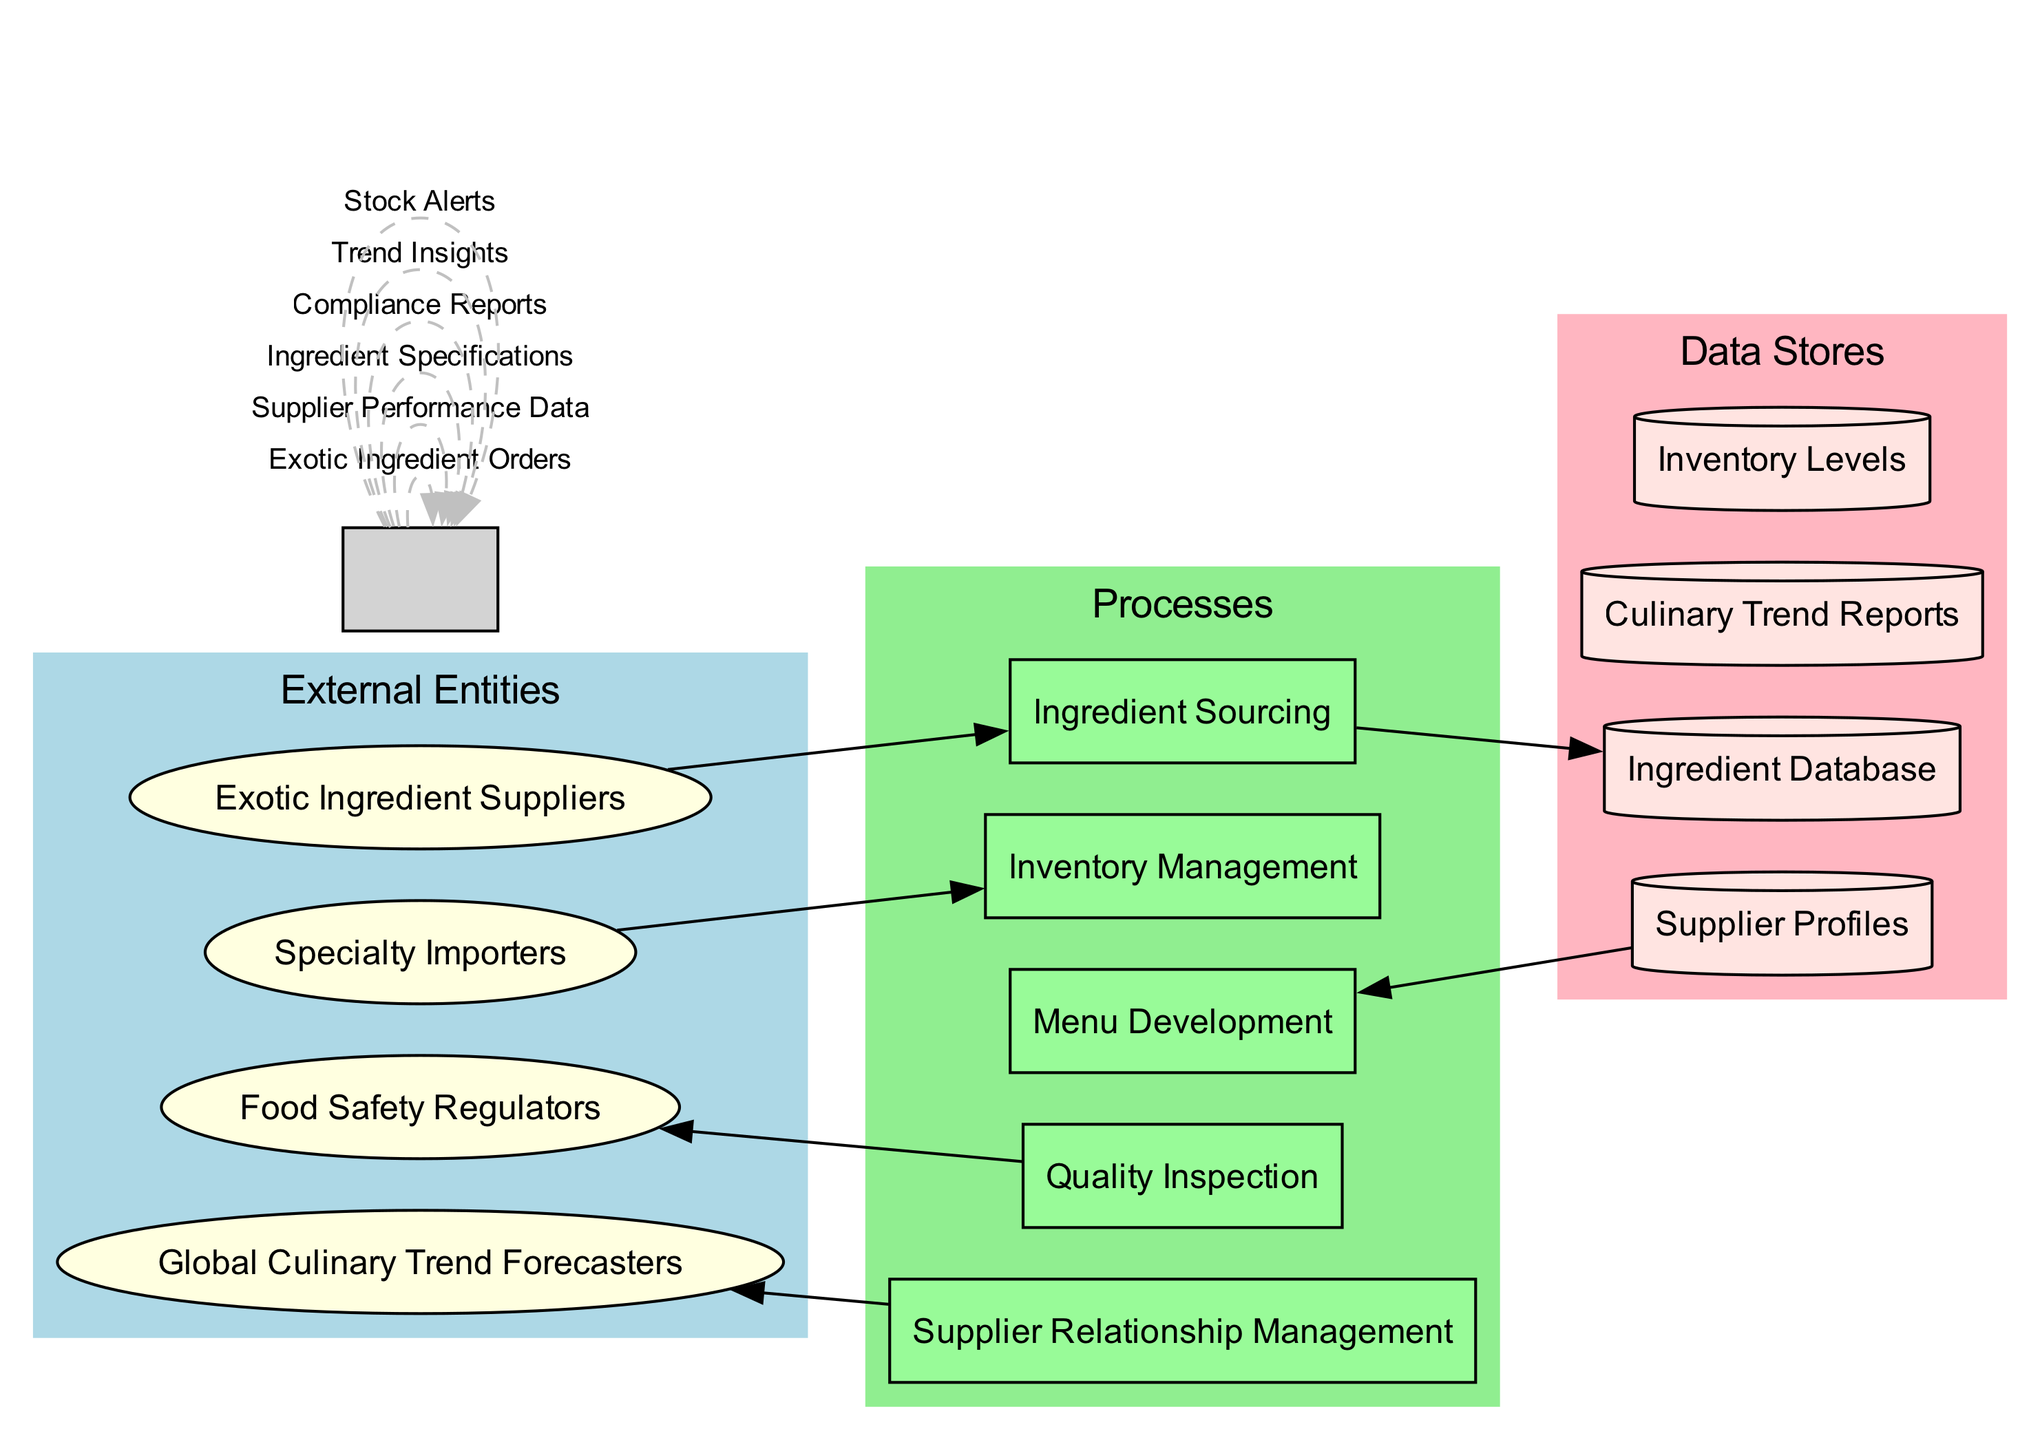What are the external entities listed in the diagram? The diagram lists four external entities: Exotic Ingredient Suppliers, Food Safety Regulators, Specialty Importers, and Global Culinary Trend Forecasters. These are shown as ovals in the "External Entities" section of the diagram.
Answer: Exotic Ingredient Suppliers, Food Safety Regulators, Specialty Importers, Global Culinary Trend Forecasters How many processes are there in the diagram? There are five processes: Ingredient Sourcing, Quality Inspection, Menu Development, Inventory Management, and Supplier Relationship Management. Each of these is represented as a rectangle in the "Processes" section of the diagram.
Answer: Five Which process is connected to Supplier Relationship Management? The Supplier Relationship Management process is connected to the Global Culinary Trend Forecasters external entity. This connection indicates a flow of information from the forecasters to the management process.
Answer: Global Culinary Trend Forecasters What type of data store is used for tracking inventory levels? Inventory Levels is represented as a cylinder in the diagram, which indicates it is a data store specifically used to track inventory levels. The cylinder shape is standard in data flow diagrams to denote data stores.
Answer: Cylinder Which data flow is labeled as "Trend Insights"? The "Trend Insights" data flow connects the Global Culinary Trend Forecasters to the Supplier Relationship Management process, indicating the transfer of insights into culinary trends from external forecasters to the management process.
Answer: Supplier Relationship Management What is the flow between Ingredient Sourcing and the Ingredient Database? The flow between Ingredient Sourcing and the Ingredient Database conveys the Exotic Ingredient Orders, which means that orders for exotic ingredients are stored in the Ingredient Database after being sourced.
Answer: Exotic Ingredient Orders Which process takes in Compliance Reports? The Quality Inspection process takes in Compliance Reports. This indicates that the quality of exotic ingredients is assessed in relation to compliance with food safety regulations using the reports received.
Answer: Quality Inspection What data flows from the Inventory Levels data store? The Stock Alerts flow is directed from the Inventory Levels data store, indicating that alerts related to stock levels are generated based on data stored in this data store.
Answer: Stock Alerts How many data stores are represented in the diagram? There are four data stores depicted: Ingredient Database, Supplier Profiles, Culinary Trend Reports, and Inventory Levels. Each store is represented in the "Data Stores" section of the diagram, typically shown as cylinders.
Answer: Four 